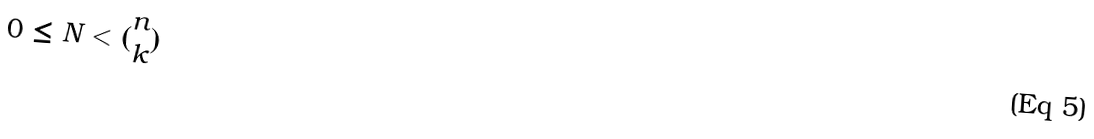Convert formula to latex. <formula><loc_0><loc_0><loc_500><loc_500>0 \leq N < ( \begin{matrix} n \\ k \end{matrix} )</formula> 